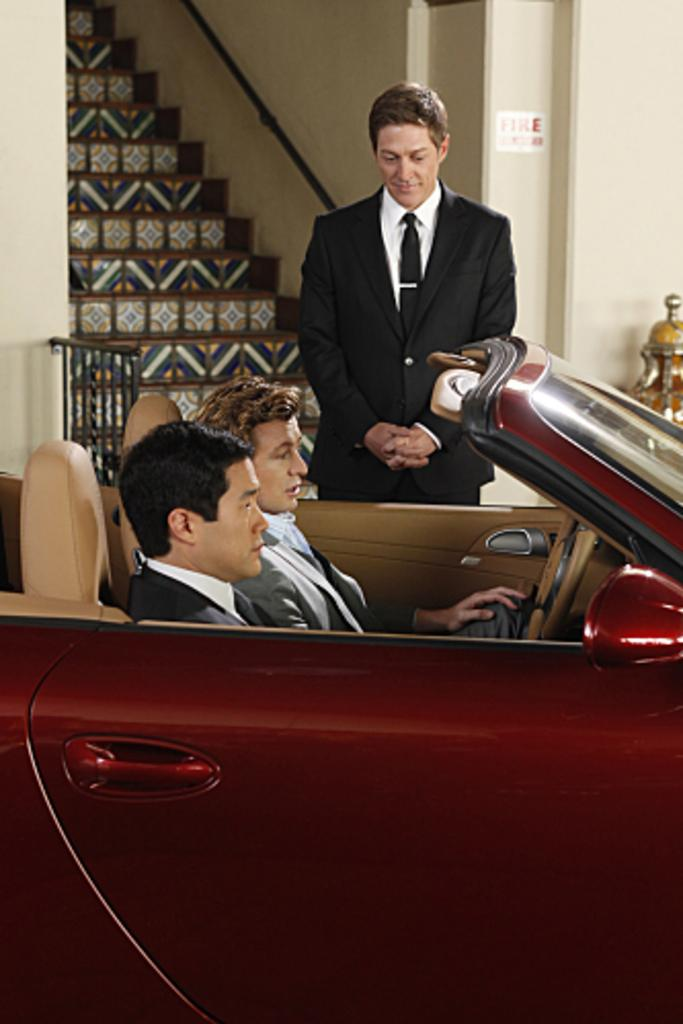How many people are present in the image? There are three people in the image. What are two of the people doing in the image? Two of the people are sitting in a car. What is the third person doing in the image? One person is standing outside the car. What type of structure can be seen in the image? There is a building in the image. What architectural feature is visible in the image? There are stairs in the image. Can you describe the earthquake happening in the image? There is no earthquake present in the image. How high is the person jumping in the image? There is no person jumping in the image; all three people are either sitting or standing. 